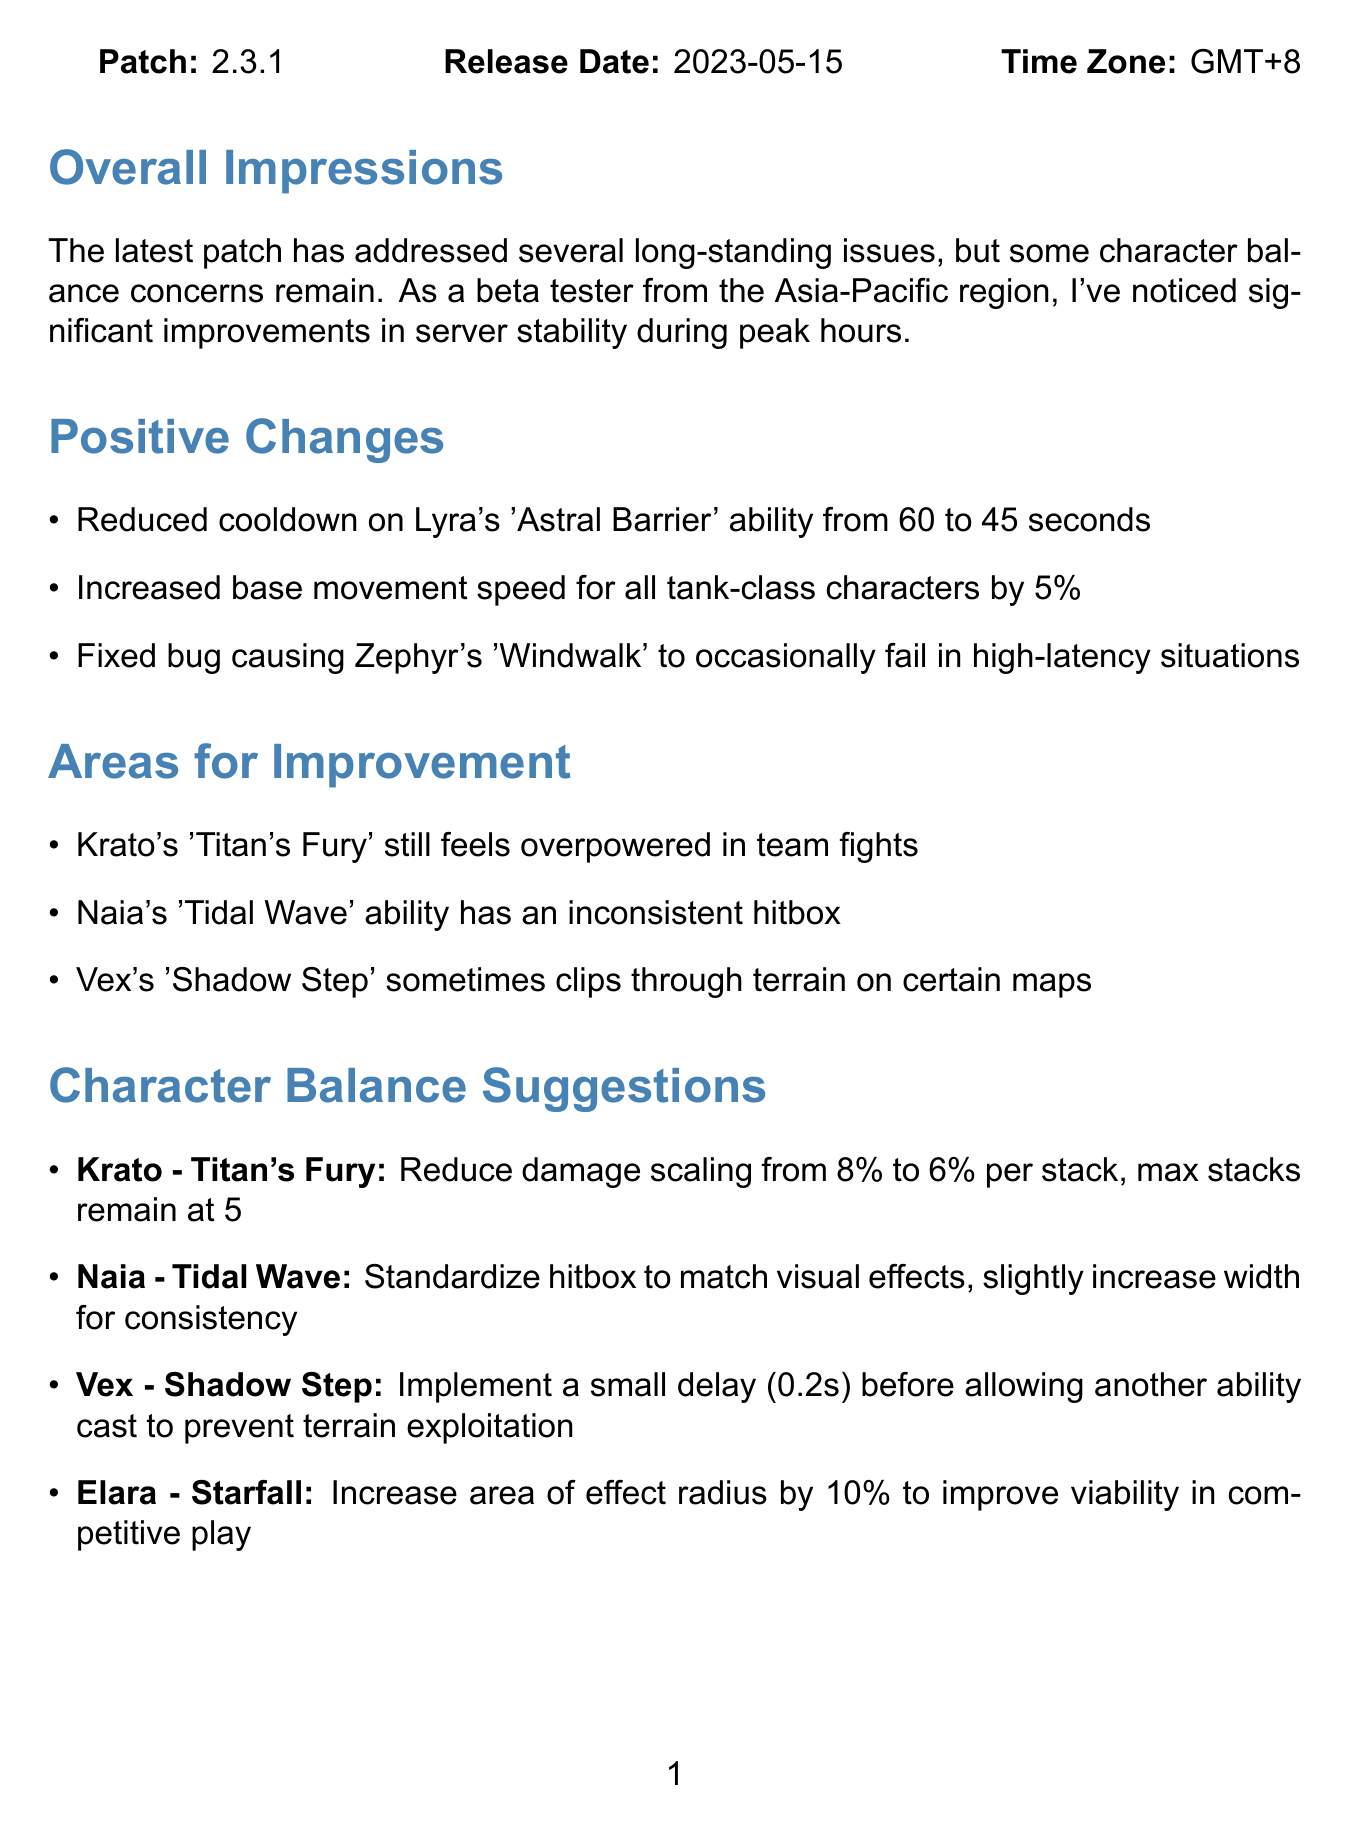What is the patch number? The patch number is explicitly stated in the document.
Answer: 2.3.1 What date was the patch released? The release date is clearly mentioned in the document.
Answer: 2023-05-15 Who is the beta tester for this feedback? The beta tester's name is listed in the signature section of the document.
Answer: Alex Chen What ability had its cooldown reduced? The positive changes in the document detail this specific ability.
Answer: Lyra's 'Astral Barrier' Which character's ability has an inconsistent hitbox? This issue is categorized under areas for improvement in the document.
Answer: Naia's 'Tidal Wave' What is the suggested change for Krato's 'Titan's Fury'? The character balance suggestions section provides this detail.
Answer: Reduce damage scaling from 8% to 6% per stack What is the effect of the new 'Celestial Ruins' map? The additional observations section explicitly describes this issue.
Answer: Projectiles pass through walls How much have the loading times decreased? The document states this specific improvement under additional observations.
Answer: Approximately 20% What is the testing hours mentioned in the signature? The signature section lists the number of testing hours completed.
Answer: 37 